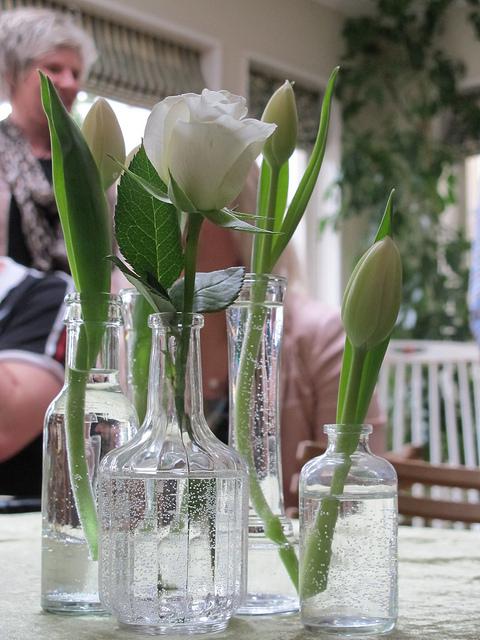How many vases that has a rose in it?
Short answer required. 1. What type of flower is in the vase?
Short answer required. Rose. Are all of the flowers open?
Write a very short answer. No. 